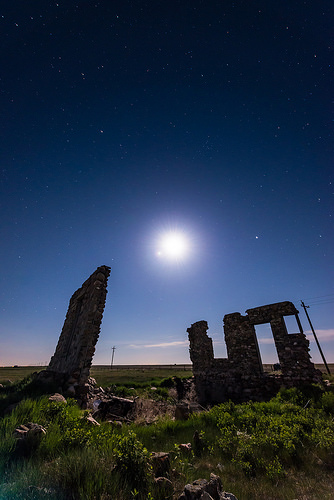<image>
Is the stone under the sky? Yes. The stone is positioned underneath the sky, with the sky above it in the vertical space. Is there a sky behind the structure? Yes. From this viewpoint, the sky is positioned behind the structure, with the structure partially or fully occluding the sky. Is there a building in front of the rubble? No. The building is not in front of the rubble. The spatial positioning shows a different relationship between these objects. 